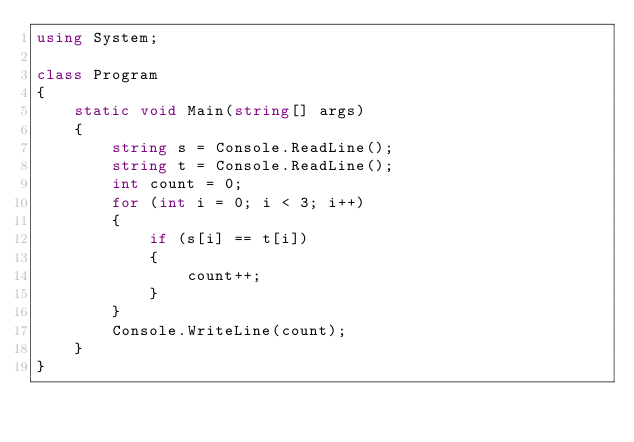Convert code to text. <code><loc_0><loc_0><loc_500><loc_500><_C#_>using System;

class Program
{
    static void Main(string[] args)
    {
        string s = Console.ReadLine();
        string t = Console.ReadLine();
        int count = 0;
        for (int i = 0; i < 3; i++)
        {
            if (s[i] == t[i])
            {
                count++;
            }
        }
        Console.WriteLine(count);
    }
}
</code> 